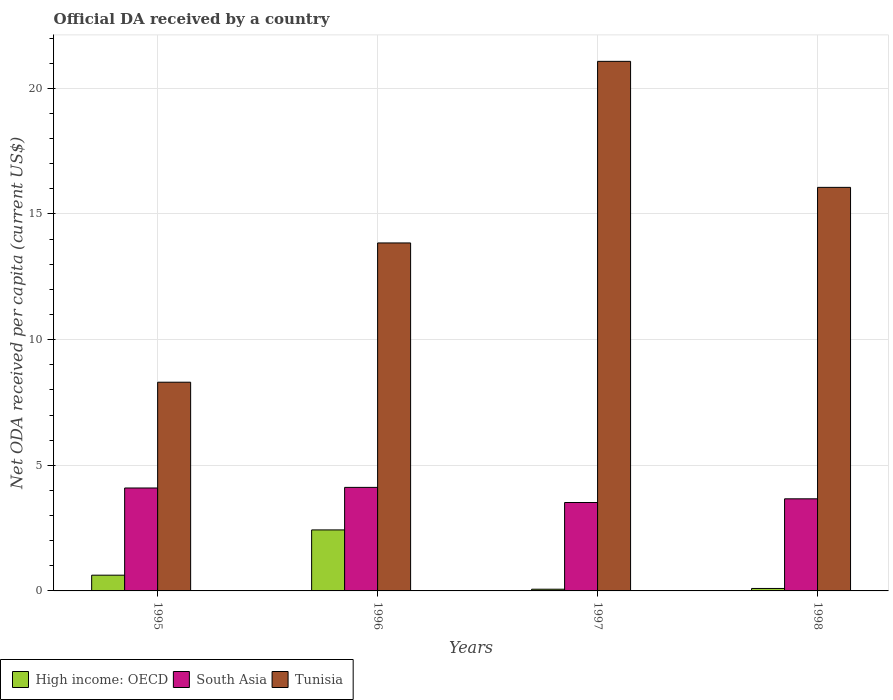How many different coloured bars are there?
Give a very brief answer. 3. How many bars are there on the 3rd tick from the right?
Give a very brief answer. 3. What is the ODA received in in Tunisia in 1996?
Your response must be concise. 13.85. Across all years, what is the maximum ODA received in in South Asia?
Ensure brevity in your answer.  4.12. Across all years, what is the minimum ODA received in in Tunisia?
Offer a very short reply. 8.31. In which year was the ODA received in in Tunisia minimum?
Provide a short and direct response. 1995. What is the total ODA received in in High income: OECD in the graph?
Your answer should be compact. 3.22. What is the difference between the ODA received in in South Asia in 1995 and that in 1997?
Your answer should be very brief. 0.58. What is the difference between the ODA received in in Tunisia in 1996 and the ODA received in in High income: OECD in 1995?
Offer a terse response. 13.22. What is the average ODA received in in High income: OECD per year?
Offer a terse response. 0.81. In the year 1995, what is the difference between the ODA received in in High income: OECD and ODA received in in Tunisia?
Offer a very short reply. -7.68. What is the ratio of the ODA received in in High income: OECD in 1996 to that in 1997?
Ensure brevity in your answer.  35.81. Is the ODA received in in South Asia in 1996 less than that in 1997?
Keep it short and to the point. No. What is the difference between the highest and the second highest ODA received in in South Asia?
Ensure brevity in your answer.  0.02. What is the difference between the highest and the lowest ODA received in in Tunisia?
Your answer should be very brief. 12.77. In how many years, is the ODA received in in High income: OECD greater than the average ODA received in in High income: OECD taken over all years?
Make the answer very short. 1. What does the 1st bar from the left in 1997 represents?
Ensure brevity in your answer.  High income: OECD. How many bars are there?
Give a very brief answer. 12. How many years are there in the graph?
Your answer should be compact. 4. Are the values on the major ticks of Y-axis written in scientific E-notation?
Give a very brief answer. No. Where does the legend appear in the graph?
Keep it short and to the point. Bottom left. How are the legend labels stacked?
Provide a succinct answer. Horizontal. What is the title of the graph?
Your answer should be compact. Official DA received by a country. What is the label or title of the X-axis?
Provide a short and direct response. Years. What is the label or title of the Y-axis?
Your response must be concise. Net ODA received per capita (current US$). What is the Net ODA received per capita (current US$) of High income: OECD in 1995?
Give a very brief answer. 0.63. What is the Net ODA received per capita (current US$) of South Asia in 1995?
Your response must be concise. 4.1. What is the Net ODA received per capita (current US$) of Tunisia in 1995?
Provide a succinct answer. 8.31. What is the Net ODA received per capita (current US$) of High income: OECD in 1996?
Your answer should be very brief. 2.43. What is the Net ODA received per capita (current US$) in South Asia in 1996?
Your answer should be compact. 4.12. What is the Net ODA received per capita (current US$) of Tunisia in 1996?
Provide a succinct answer. 13.85. What is the Net ODA received per capita (current US$) of High income: OECD in 1997?
Your response must be concise. 0.07. What is the Net ODA received per capita (current US$) of South Asia in 1997?
Ensure brevity in your answer.  3.52. What is the Net ODA received per capita (current US$) of Tunisia in 1997?
Your answer should be very brief. 21.07. What is the Net ODA received per capita (current US$) of High income: OECD in 1998?
Make the answer very short. 0.1. What is the Net ODA received per capita (current US$) in South Asia in 1998?
Your response must be concise. 3.67. What is the Net ODA received per capita (current US$) in Tunisia in 1998?
Keep it short and to the point. 16.06. Across all years, what is the maximum Net ODA received per capita (current US$) of High income: OECD?
Keep it short and to the point. 2.43. Across all years, what is the maximum Net ODA received per capita (current US$) of South Asia?
Your response must be concise. 4.12. Across all years, what is the maximum Net ODA received per capita (current US$) in Tunisia?
Offer a terse response. 21.07. Across all years, what is the minimum Net ODA received per capita (current US$) in High income: OECD?
Provide a succinct answer. 0.07. Across all years, what is the minimum Net ODA received per capita (current US$) of South Asia?
Give a very brief answer. 3.52. Across all years, what is the minimum Net ODA received per capita (current US$) of Tunisia?
Your answer should be very brief. 8.31. What is the total Net ODA received per capita (current US$) in High income: OECD in the graph?
Provide a succinct answer. 3.22. What is the total Net ODA received per capita (current US$) of South Asia in the graph?
Keep it short and to the point. 15.4. What is the total Net ODA received per capita (current US$) of Tunisia in the graph?
Give a very brief answer. 59.29. What is the difference between the Net ODA received per capita (current US$) of High income: OECD in 1995 and that in 1996?
Provide a short and direct response. -1.8. What is the difference between the Net ODA received per capita (current US$) of South Asia in 1995 and that in 1996?
Your answer should be compact. -0.02. What is the difference between the Net ODA received per capita (current US$) in Tunisia in 1995 and that in 1996?
Keep it short and to the point. -5.54. What is the difference between the Net ODA received per capita (current US$) of High income: OECD in 1995 and that in 1997?
Offer a terse response. 0.56. What is the difference between the Net ODA received per capita (current US$) in South Asia in 1995 and that in 1997?
Provide a succinct answer. 0.58. What is the difference between the Net ODA received per capita (current US$) of Tunisia in 1995 and that in 1997?
Your answer should be very brief. -12.77. What is the difference between the Net ODA received per capita (current US$) in High income: OECD in 1995 and that in 1998?
Your response must be concise. 0.53. What is the difference between the Net ODA received per capita (current US$) of South Asia in 1995 and that in 1998?
Keep it short and to the point. 0.43. What is the difference between the Net ODA received per capita (current US$) of Tunisia in 1995 and that in 1998?
Provide a succinct answer. -7.75. What is the difference between the Net ODA received per capita (current US$) in High income: OECD in 1996 and that in 1997?
Ensure brevity in your answer.  2.36. What is the difference between the Net ODA received per capita (current US$) in South Asia in 1996 and that in 1997?
Keep it short and to the point. 0.6. What is the difference between the Net ODA received per capita (current US$) in Tunisia in 1996 and that in 1997?
Ensure brevity in your answer.  -7.23. What is the difference between the Net ODA received per capita (current US$) in High income: OECD in 1996 and that in 1998?
Offer a very short reply. 2.33. What is the difference between the Net ODA received per capita (current US$) in South Asia in 1996 and that in 1998?
Provide a short and direct response. 0.46. What is the difference between the Net ODA received per capita (current US$) in Tunisia in 1996 and that in 1998?
Give a very brief answer. -2.21. What is the difference between the Net ODA received per capita (current US$) of High income: OECD in 1997 and that in 1998?
Make the answer very short. -0.03. What is the difference between the Net ODA received per capita (current US$) of South Asia in 1997 and that in 1998?
Ensure brevity in your answer.  -0.15. What is the difference between the Net ODA received per capita (current US$) in Tunisia in 1997 and that in 1998?
Make the answer very short. 5.01. What is the difference between the Net ODA received per capita (current US$) in High income: OECD in 1995 and the Net ODA received per capita (current US$) in South Asia in 1996?
Make the answer very short. -3.49. What is the difference between the Net ODA received per capita (current US$) in High income: OECD in 1995 and the Net ODA received per capita (current US$) in Tunisia in 1996?
Keep it short and to the point. -13.22. What is the difference between the Net ODA received per capita (current US$) of South Asia in 1995 and the Net ODA received per capita (current US$) of Tunisia in 1996?
Provide a short and direct response. -9.75. What is the difference between the Net ODA received per capita (current US$) of High income: OECD in 1995 and the Net ODA received per capita (current US$) of South Asia in 1997?
Your answer should be very brief. -2.89. What is the difference between the Net ODA received per capita (current US$) of High income: OECD in 1995 and the Net ODA received per capita (current US$) of Tunisia in 1997?
Your response must be concise. -20.45. What is the difference between the Net ODA received per capita (current US$) of South Asia in 1995 and the Net ODA received per capita (current US$) of Tunisia in 1997?
Ensure brevity in your answer.  -16.98. What is the difference between the Net ODA received per capita (current US$) in High income: OECD in 1995 and the Net ODA received per capita (current US$) in South Asia in 1998?
Offer a very short reply. -3.04. What is the difference between the Net ODA received per capita (current US$) in High income: OECD in 1995 and the Net ODA received per capita (current US$) in Tunisia in 1998?
Offer a terse response. -15.43. What is the difference between the Net ODA received per capita (current US$) of South Asia in 1995 and the Net ODA received per capita (current US$) of Tunisia in 1998?
Provide a short and direct response. -11.96. What is the difference between the Net ODA received per capita (current US$) of High income: OECD in 1996 and the Net ODA received per capita (current US$) of South Asia in 1997?
Provide a succinct answer. -1.09. What is the difference between the Net ODA received per capita (current US$) of High income: OECD in 1996 and the Net ODA received per capita (current US$) of Tunisia in 1997?
Ensure brevity in your answer.  -18.65. What is the difference between the Net ODA received per capita (current US$) in South Asia in 1996 and the Net ODA received per capita (current US$) in Tunisia in 1997?
Provide a succinct answer. -16.95. What is the difference between the Net ODA received per capita (current US$) in High income: OECD in 1996 and the Net ODA received per capita (current US$) in South Asia in 1998?
Keep it short and to the point. -1.24. What is the difference between the Net ODA received per capita (current US$) in High income: OECD in 1996 and the Net ODA received per capita (current US$) in Tunisia in 1998?
Your response must be concise. -13.63. What is the difference between the Net ODA received per capita (current US$) of South Asia in 1996 and the Net ODA received per capita (current US$) of Tunisia in 1998?
Your answer should be compact. -11.94. What is the difference between the Net ODA received per capita (current US$) of High income: OECD in 1997 and the Net ODA received per capita (current US$) of South Asia in 1998?
Your response must be concise. -3.6. What is the difference between the Net ODA received per capita (current US$) of High income: OECD in 1997 and the Net ODA received per capita (current US$) of Tunisia in 1998?
Offer a very short reply. -15.99. What is the difference between the Net ODA received per capita (current US$) of South Asia in 1997 and the Net ODA received per capita (current US$) of Tunisia in 1998?
Ensure brevity in your answer.  -12.54. What is the average Net ODA received per capita (current US$) of High income: OECD per year?
Your answer should be very brief. 0.81. What is the average Net ODA received per capita (current US$) of South Asia per year?
Offer a very short reply. 3.85. What is the average Net ODA received per capita (current US$) of Tunisia per year?
Your answer should be very brief. 14.82. In the year 1995, what is the difference between the Net ODA received per capita (current US$) in High income: OECD and Net ODA received per capita (current US$) in South Asia?
Offer a very short reply. -3.47. In the year 1995, what is the difference between the Net ODA received per capita (current US$) in High income: OECD and Net ODA received per capita (current US$) in Tunisia?
Your answer should be very brief. -7.68. In the year 1995, what is the difference between the Net ODA received per capita (current US$) in South Asia and Net ODA received per capita (current US$) in Tunisia?
Offer a terse response. -4.21. In the year 1996, what is the difference between the Net ODA received per capita (current US$) of High income: OECD and Net ODA received per capita (current US$) of South Asia?
Keep it short and to the point. -1.69. In the year 1996, what is the difference between the Net ODA received per capita (current US$) in High income: OECD and Net ODA received per capita (current US$) in Tunisia?
Ensure brevity in your answer.  -11.42. In the year 1996, what is the difference between the Net ODA received per capita (current US$) in South Asia and Net ODA received per capita (current US$) in Tunisia?
Offer a very short reply. -9.73. In the year 1997, what is the difference between the Net ODA received per capita (current US$) in High income: OECD and Net ODA received per capita (current US$) in South Asia?
Offer a very short reply. -3.45. In the year 1997, what is the difference between the Net ODA received per capita (current US$) in High income: OECD and Net ODA received per capita (current US$) in Tunisia?
Keep it short and to the point. -21.01. In the year 1997, what is the difference between the Net ODA received per capita (current US$) of South Asia and Net ODA received per capita (current US$) of Tunisia?
Keep it short and to the point. -17.56. In the year 1998, what is the difference between the Net ODA received per capita (current US$) of High income: OECD and Net ODA received per capita (current US$) of South Asia?
Offer a very short reply. -3.57. In the year 1998, what is the difference between the Net ODA received per capita (current US$) of High income: OECD and Net ODA received per capita (current US$) of Tunisia?
Keep it short and to the point. -15.96. In the year 1998, what is the difference between the Net ODA received per capita (current US$) in South Asia and Net ODA received per capita (current US$) in Tunisia?
Provide a succinct answer. -12.39. What is the ratio of the Net ODA received per capita (current US$) of High income: OECD in 1995 to that in 1996?
Give a very brief answer. 0.26. What is the ratio of the Net ODA received per capita (current US$) of South Asia in 1995 to that in 1996?
Give a very brief answer. 0.99. What is the ratio of the Net ODA received per capita (current US$) of Tunisia in 1995 to that in 1996?
Make the answer very short. 0.6. What is the ratio of the Net ODA received per capita (current US$) of High income: OECD in 1995 to that in 1997?
Your response must be concise. 9.24. What is the ratio of the Net ODA received per capita (current US$) of South Asia in 1995 to that in 1997?
Your response must be concise. 1.16. What is the ratio of the Net ODA received per capita (current US$) of Tunisia in 1995 to that in 1997?
Your response must be concise. 0.39. What is the ratio of the Net ODA received per capita (current US$) of High income: OECD in 1995 to that in 1998?
Your answer should be very brief. 6.4. What is the ratio of the Net ODA received per capita (current US$) in South Asia in 1995 to that in 1998?
Provide a short and direct response. 1.12. What is the ratio of the Net ODA received per capita (current US$) in Tunisia in 1995 to that in 1998?
Offer a very short reply. 0.52. What is the ratio of the Net ODA received per capita (current US$) of High income: OECD in 1996 to that in 1997?
Provide a short and direct response. 35.81. What is the ratio of the Net ODA received per capita (current US$) in South Asia in 1996 to that in 1997?
Give a very brief answer. 1.17. What is the ratio of the Net ODA received per capita (current US$) in Tunisia in 1996 to that in 1997?
Ensure brevity in your answer.  0.66. What is the ratio of the Net ODA received per capita (current US$) of High income: OECD in 1996 to that in 1998?
Offer a terse response. 24.79. What is the ratio of the Net ODA received per capita (current US$) in South Asia in 1996 to that in 1998?
Offer a very short reply. 1.12. What is the ratio of the Net ODA received per capita (current US$) of Tunisia in 1996 to that in 1998?
Ensure brevity in your answer.  0.86. What is the ratio of the Net ODA received per capita (current US$) of High income: OECD in 1997 to that in 1998?
Provide a short and direct response. 0.69. What is the ratio of the Net ODA received per capita (current US$) of South Asia in 1997 to that in 1998?
Offer a terse response. 0.96. What is the ratio of the Net ODA received per capita (current US$) of Tunisia in 1997 to that in 1998?
Ensure brevity in your answer.  1.31. What is the difference between the highest and the second highest Net ODA received per capita (current US$) in High income: OECD?
Offer a terse response. 1.8. What is the difference between the highest and the second highest Net ODA received per capita (current US$) in South Asia?
Keep it short and to the point. 0.02. What is the difference between the highest and the second highest Net ODA received per capita (current US$) in Tunisia?
Provide a succinct answer. 5.01. What is the difference between the highest and the lowest Net ODA received per capita (current US$) of High income: OECD?
Make the answer very short. 2.36. What is the difference between the highest and the lowest Net ODA received per capita (current US$) in South Asia?
Keep it short and to the point. 0.6. What is the difference between the highest and the lowest Net ODA received per capita (current US$) in Tunisia?
Your answer should be very brief. 12.77. 